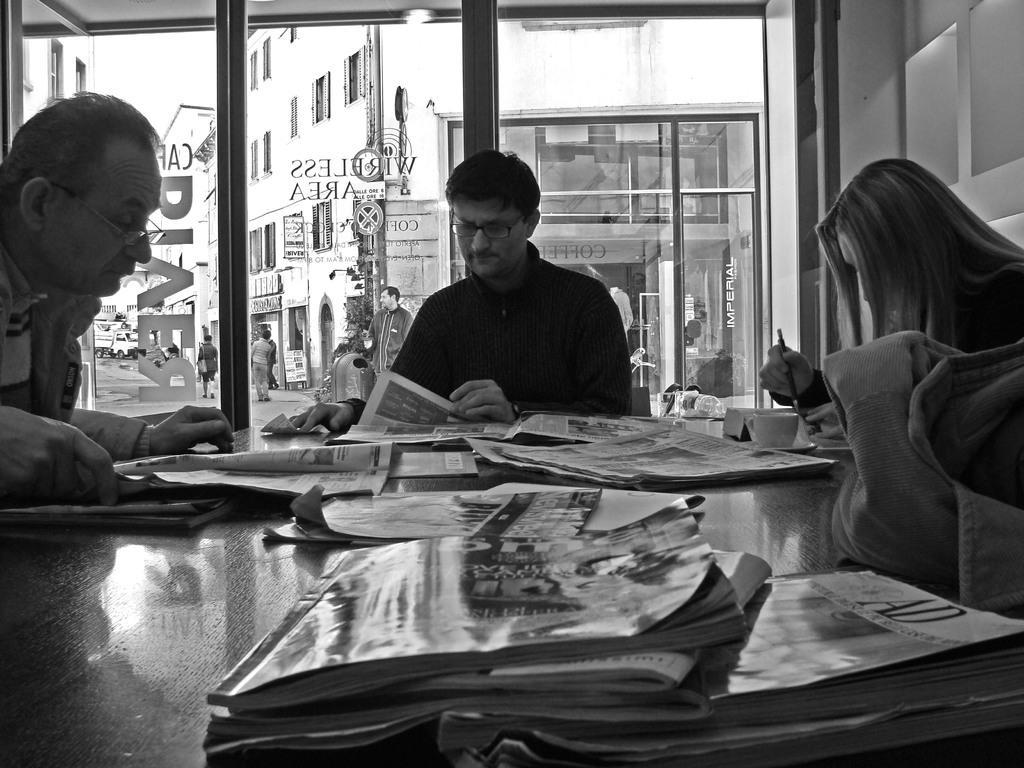How would you summarize this image in a sentence or two? There is a table in the image, on that table there are some newspapers and two men sitting on the chairs reading newspapers and a woman sitting on and eating food and in the background there is a glass door. 